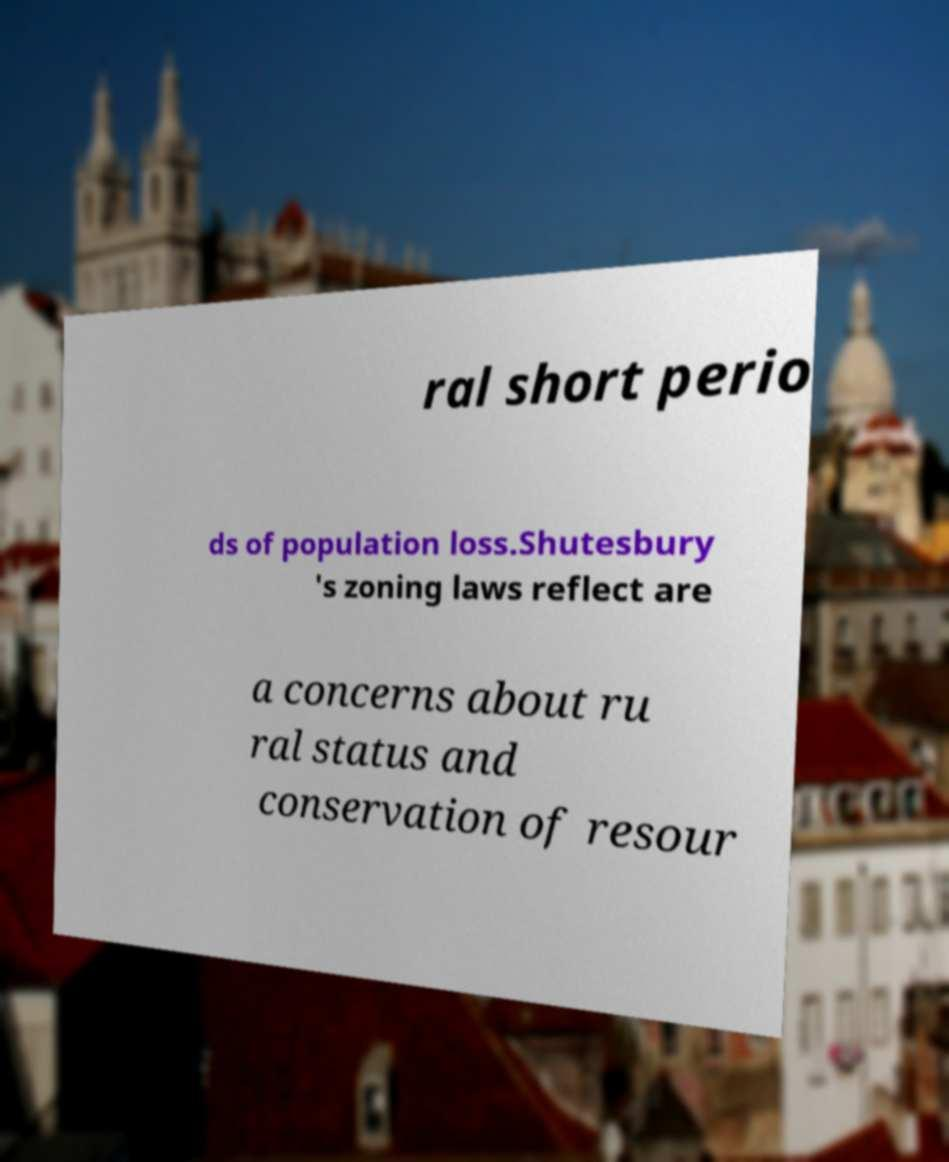Could you extract and type out the text from this image? ral short perio ds of population loss.Shutesbury 's zoning laws reflect are a concerns about ru ral status and conservation of resour 